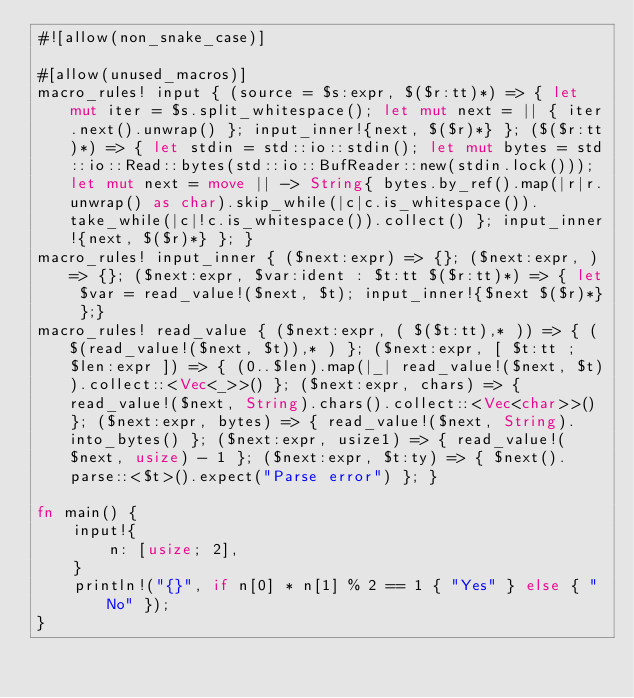Convert code to text. <code><loc_0><loc_0><loc_500><loc_500><_Rust_>#![allow(non_snake_case)]

#[allow(unused_macros)]
macro_rules! input { (source = $s:expr, $($r:tt)*) => { let mut iter = $s.split_whitespace(); let mut next = || { iter.next().unwrap() }; input_inner!{next, $($r)*} }; ($($r:tt)*) => { let stdin = std::io::stdin(); let mut bytes = std::io::Read::bytes(std::io::BufReader::new(stdin.lock())); let mut next = move || -> String{ bytes.by_ref().map(|r|r.unwrap() as char).skip_while(|c|c.is_whitespace()).take_while(|c|!c.is_whitespace()).collect() }; input_inner!{next, $($r)*} }; }
macro_rules! input_inner { ($next:expr) => {}; ($next:expr, ) => {}; ($next:expr, $var:ident : $t:tt $($r:tt)*) => { let $var = read_value!($next, $t); input_inner!{$next $($r)*} };}
macro_rules! read_value { ($next:expr, ( $($t:tt),* )) => { ( $(read_value!($next, $t)),* ) }; ($next:expr, [ $t:tt ; $len:expr ]) => { (0..$len).map(|_| read_value!($next, $t)).collect::<Vec<_>>() }; ($next:expr, chars) => { read_value!($next, String).chars().collect::<Vec<char>>() }; ($next:expr, bytes) => { read_value!($next, String).into_bytes() }; ($next:expr, usize1) => { read_value!($next, usize) - 1 }; ($next:expr, $t:ty) => { $next().parse::<$t>().expect("Parse error") }; }

fn main() {
    input!{
        n: [usize; 2],
    }
    println!("{}", if n[0] * n[1] % 2 == 1 { "Yes" } else { "No" });
}
</code> 